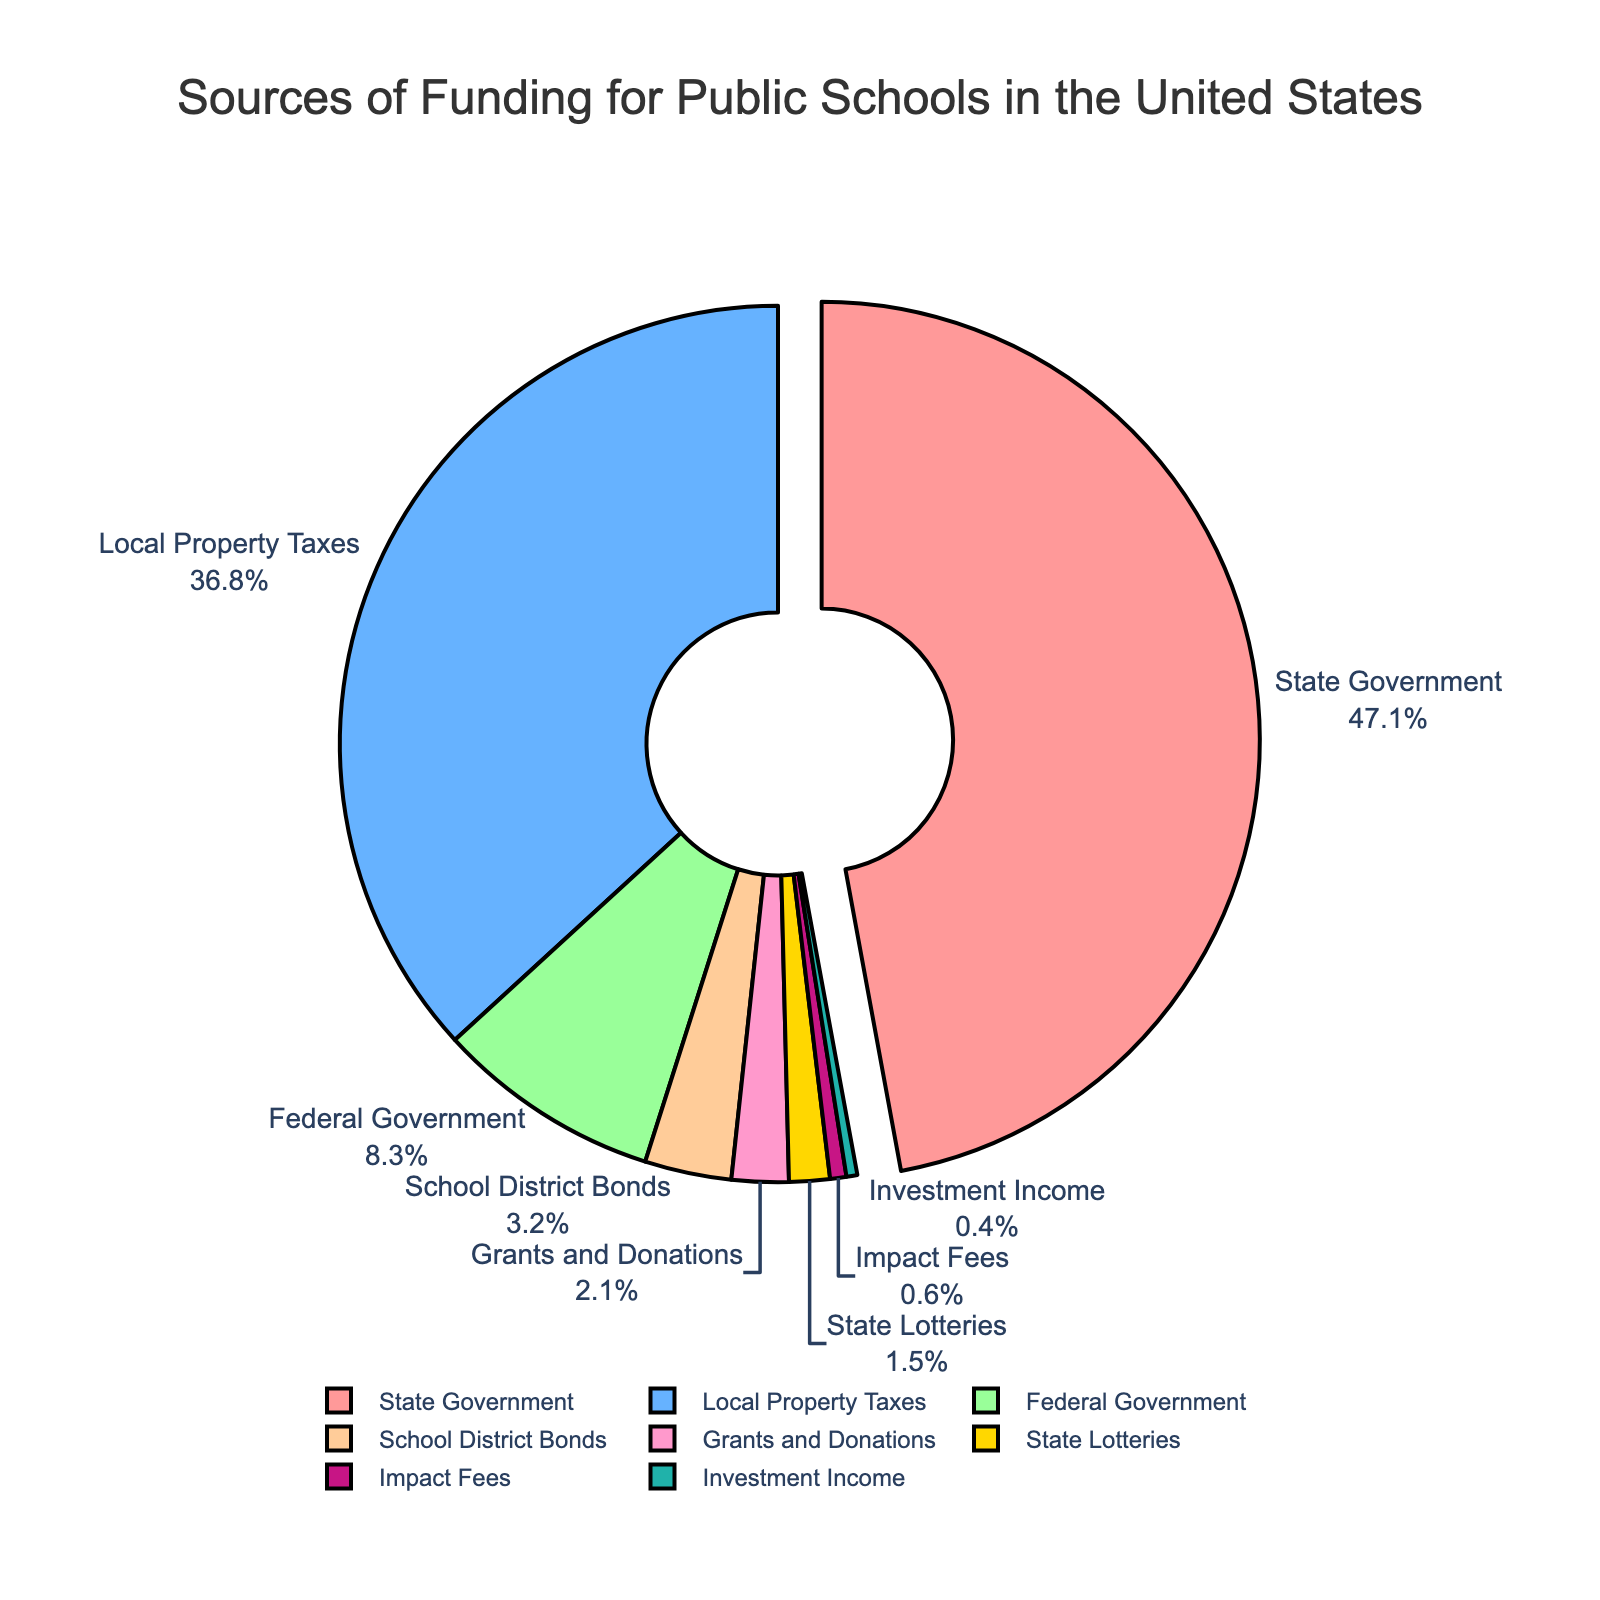What is the largest source of funding for public schools in the United States? The largest source of funding is represented by the segment pulled out from the pie, which is the State Government.
Answer: State Government Which source contributes more, Local Property Taxes or Federal Government? By looking at the percentages on the pie chart, Local Property Taxes contribute 36.8% while the Federal Government contributes 8.3%. Hence, Local Property Taxes contribute more.
Answer: Local Property Taxes What is the total percentage contribution from School District Bonds, Grants and Donations, and State Lotteries? Adding the percentages from the three sources: School District Bonds (3.2%) + Grants and Donations (2.1%) + State Lotteries (1.5%) = 6.8%.
Answer: 6.8% How does the contribution from Investment Income compare to that from Impact Fees? Investment Income contributes 0.4%, while Impact Fees contribute 0.6%; thus, Investment Income contributes less than Impact Fees.
Answer: Less Which category represents less than 1% of total funding? By looking at the segments with their percentages, both Investment Income (0.4%) and Impact Fees (0.6%) represent less than 1% of the total funding.
Answer: Investment Income, Impact Fees What is the combined contribution of the top two sources of funding? The top two sources are State Government (47.1%) and Local Property Taxes (36.8%). Adding these together results in 47.1% + 36.8% = 83.9%.
Answer: 83.9% If Federal Government and Impact Fees are combined, do they contribute more than Grants and Donations? Combining Federal Government (8.3%) and Impact Fees (0.6%) gives 8.3% + 0.6% = 8.9%. Grants and Donations contribute 2.1%. Therefore, the combined Federal Government and Impact Fees contribute more.
Answer: Yes What is the smallest source of funding? By observing the segments with their percentages, the smallest source is Investment Income with 0.4%.
Answer: Investment Income 